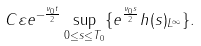Convert formula to latex. <formula><loc_0><loc_0><loc_500><loc_500>C \varepsilon e ^ { - \frac { \nu _ { 0 } t } { 2 } } \sup _ { 0 \leq s \leq T _ { 0 } } \{ e ^ { \frac { \nu _ { 0 } s } { 2 } } \| h ( s ) \| _ { L ^ { \infty } } \} .</formula> 